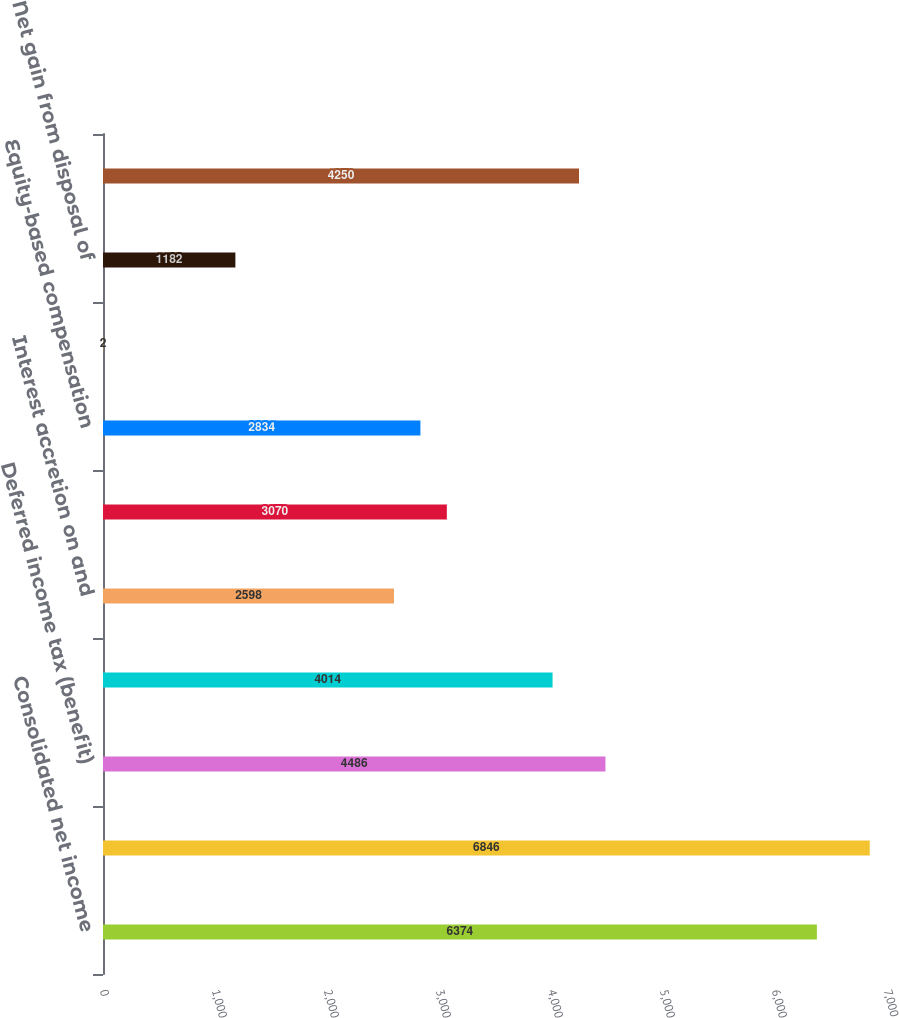Convert chart to OTSL. <chart><loc_0><loc_0><loc_500><loc_500><bar_chart><fcel>Consolidated net income<fcel>Depreciation and amortization<fcel>Deferred income tax (benefit)<fcel>Interest accretion on landfill<fcel>Interest accretion on and<fcel>Provision for bad debts<fcel>Equity-based compensation<fcel>Equity in net losses of<fcel>Net gain from disposal of<fcel>Effect of (income) expense<nl><fcel>6374<fcel>6846<fcel>4486<fcel>4014<fcel>2598<fcel>3070<fcel>2834<fcel>2<fcel>1182<fcel>4250<nl></chart> 